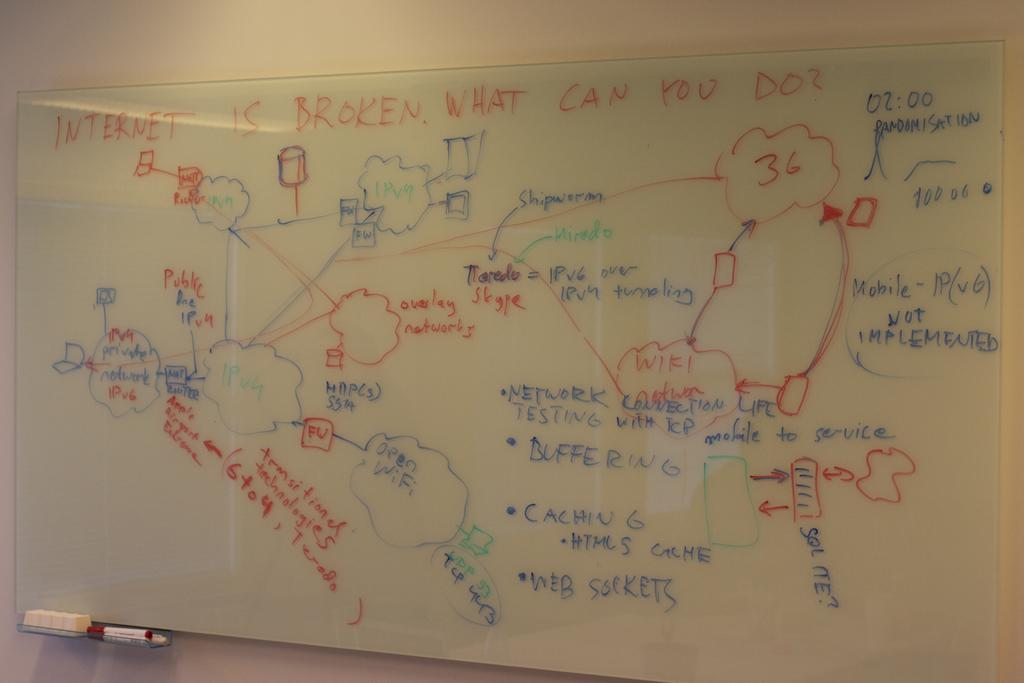Provide a one-sentence caption for the provided image. A complicated diagram provides several solutions to internet connectivity problems. 